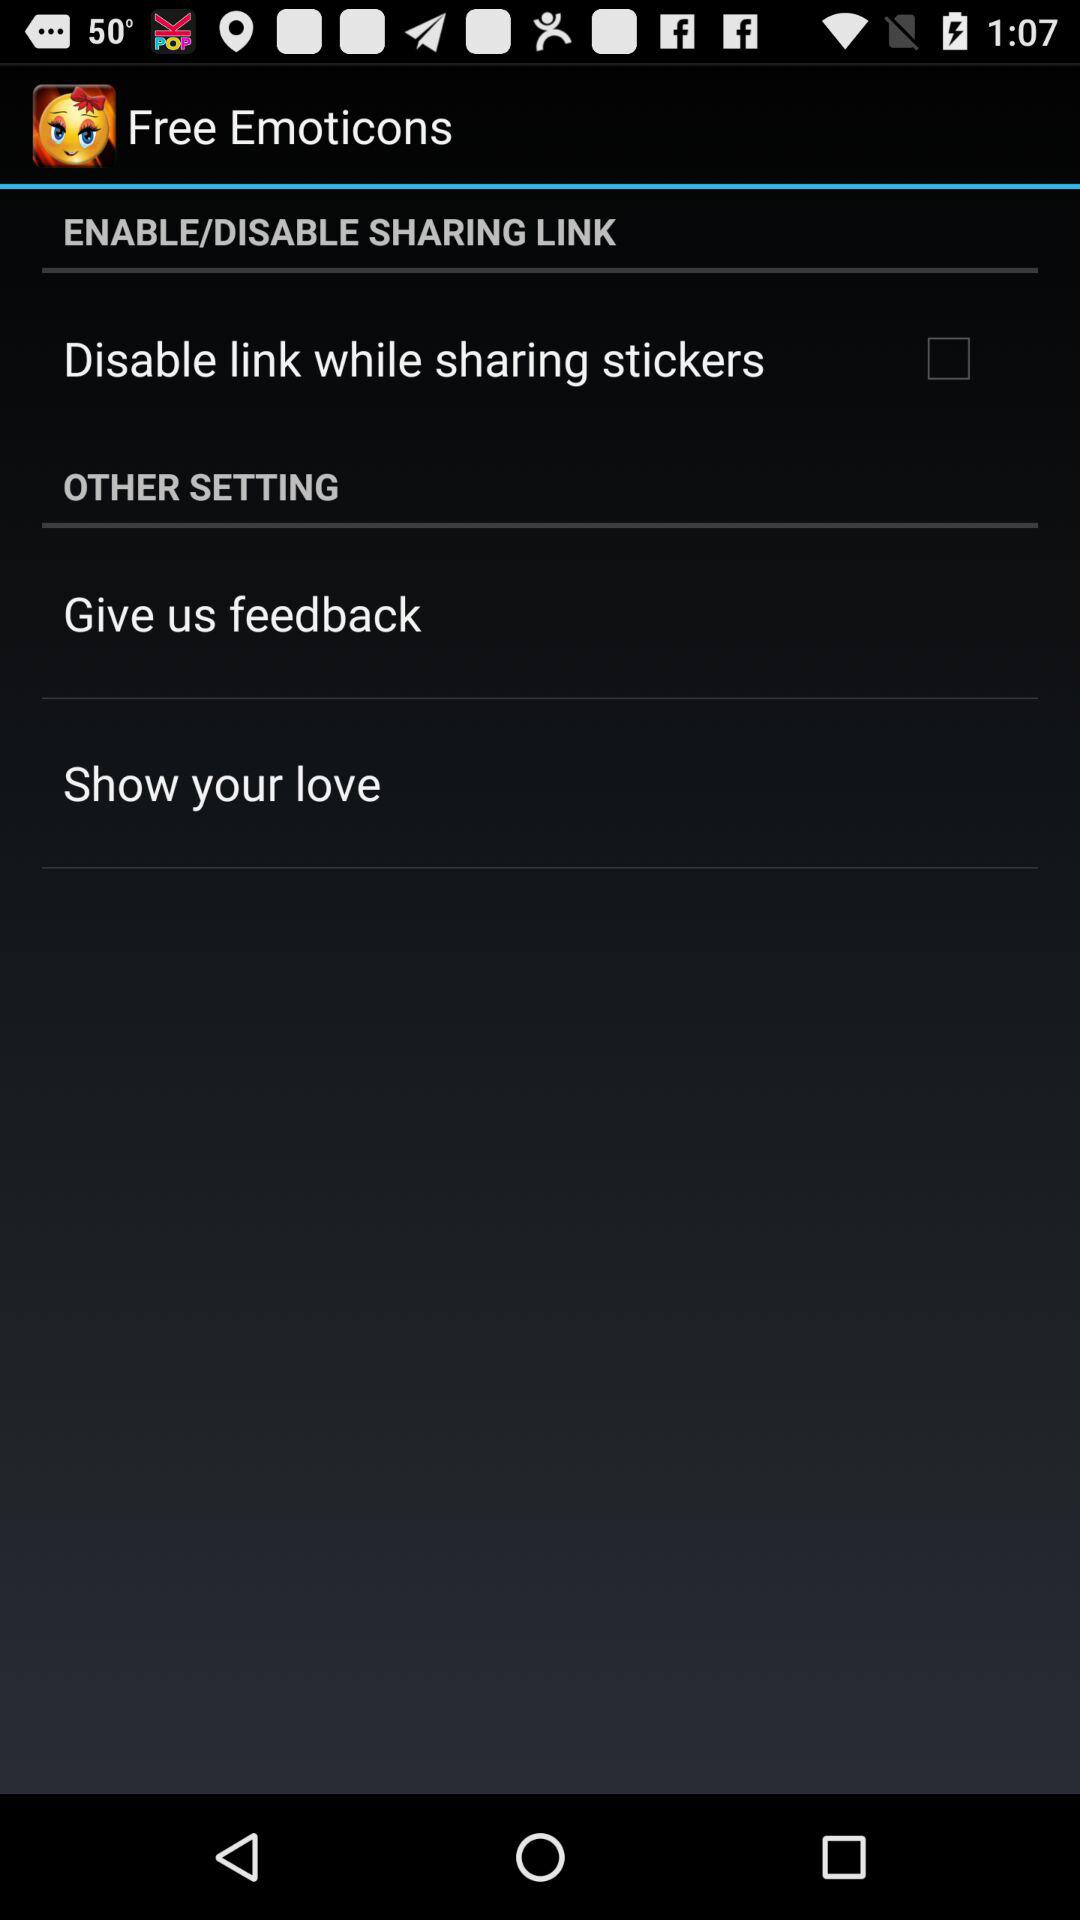What is the status of "Disable link while sharing stickers"? The status is "off". 